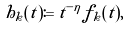<formula> <loc_0><loc_0><loc_500><loc_500>h _ { k } ( t ) \coloneqq t ^ { - \eta } f _ { k } ( t ) ,</formula> 